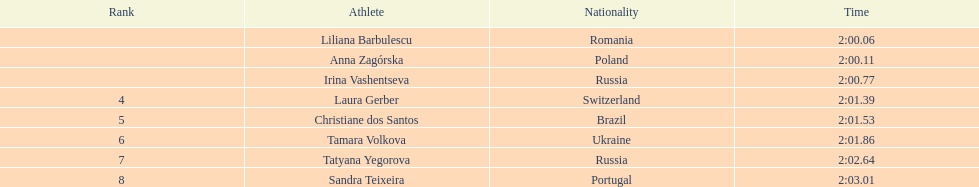What is the name of the top finalist of this semifinals heat? Liliana Barbulescu. 